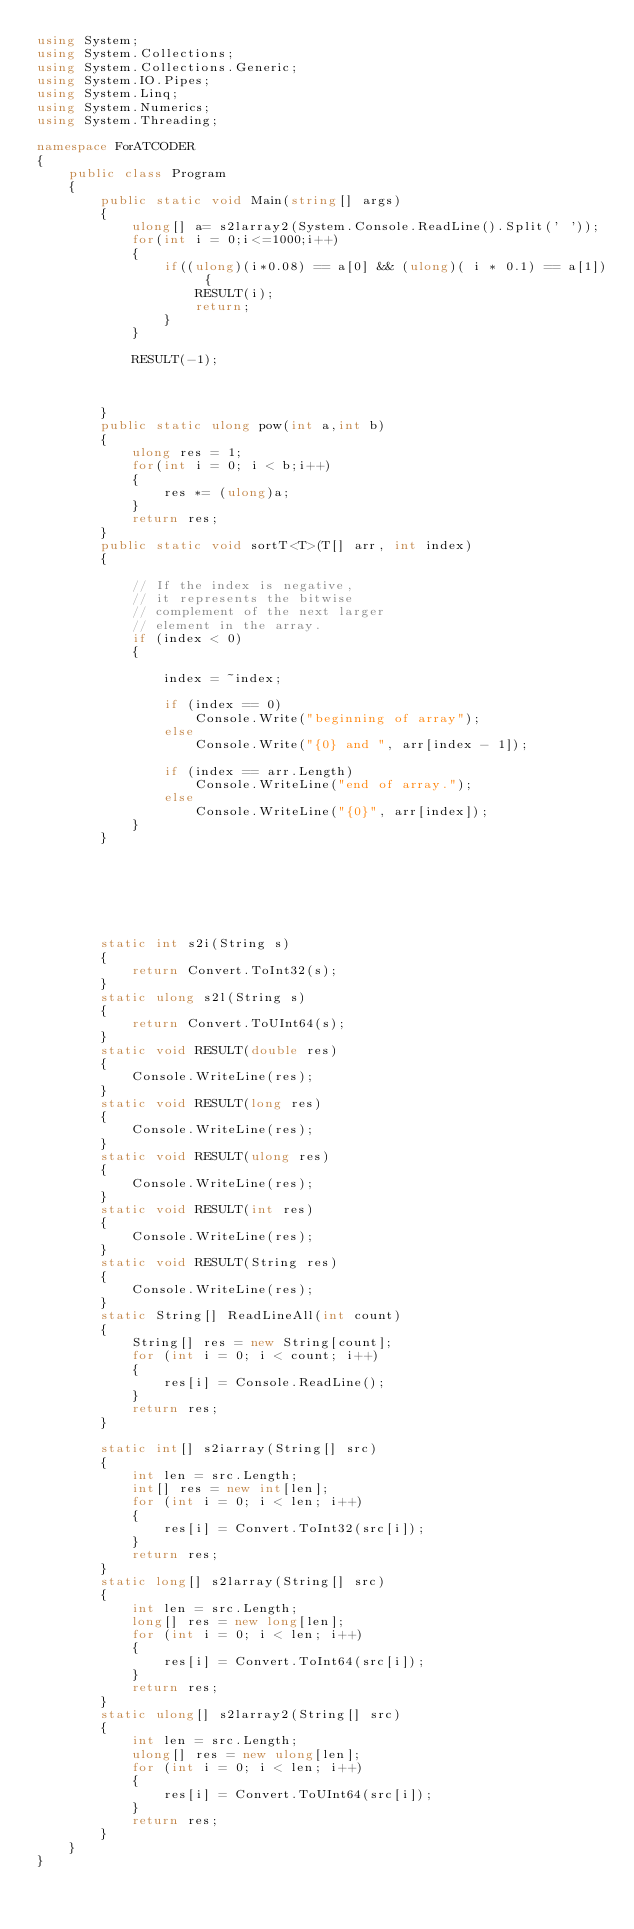Convert code to text. <code><loc_0><loc_0><loc_500><loc_500><_C#_>using System;
using System.Collections;
using System.Collections.Generic;
using System.IO.Pipes;
using System.Linq;
using System.Numerics;
using System.Threading;

namespace ForATCODER
{
    public class Program
    {
        public static void Main(string[] args)
        {
            ulong[] a= s2larray2(System.Console.ReadLine().Split(' '));
            for(int i = 0;i<=1000;i++)
            {
                if((ulong)(i*0.08) == a[0] && (ulong)( i * 0.1) == a[1]) {
                    RESULT(i);
                    return;
                }
            }
         
            RESULT(-1);

            

        }
        public static ulong pow(int a,int b)
        {
            ulong res = 1;
            for(int i = 0; i < b;i++)
            {
                res *= (ulong)a;
            }
            return res;
        }
        public static void sortT<T>(T[] arr, int index)
        {

            // If the index is negative,  
            // it represents the bitwise 
            // complement of the next larger  
            // element in the array. 
            if (index < 0)
            {

                index = ~index;

                if (index == 0)
                    Console.Write("beginning of array");
                else
                    Console.Write("{0} and ", arr[index - 1]);

                if (index == arr.Length)
                    Console.WriteLine("end of array.");
                else
                    Console.WriteLine("{0}", arr[index]);
            }
        }







        static int s2i(String s)
        {
            return Convert.ToInt32(s);
        }
        static ulong s2l(String s)
        {
            return Convert.ToUInt64(s);
        }
        static void RESULT(double res)
        {
            Console.WriteLine(res);
        }
        static void RESULT(long res)
        {
            Console.WriteLine(res);
        }
        static void RESULT(ulong res)
        {
            Console.WriteLine(res);
        }
        static void RESULT(int res)
        {
            Console.WriteLine(res);
        }
        static void RESULT(String res)
        {
            Console.WriteLine(res);
        }
        static String[] ReadLineAll(int count)
        {
            String[] res = new String[count];
            for (int i = 0; i < count; i++)
            {
                res[i] = Console.ReadLine();
            }
            return res;
        }

        static int[] s2iarray(String[] src)
        {
            int len = src.Length;
            int[] res = new int[len];
            for (int i = 0; i < len; i++)
            {
                res[i] = Convert.ToInt32(src[i]);
            }
            return res;
        }
        static long[] s2larray(String[] src)
        {
            int len = src.Length;
            long[] res = new long[len];
            for (int i = 0; i < len; i++)
            {
                res[i] = Convert.ToInt64(src[i]);
            }
            return res;
        }
        static ulong[] s2larray2(String[] src)
        {
            int len = src.Length;
            ulong[] res = new ulong[len];
            for (int i = 0; i < len; i++)
            {
                res[i] = Convert.ToUInt64(src[i]);
            }
            return res;
        }
    }
}
</code> 